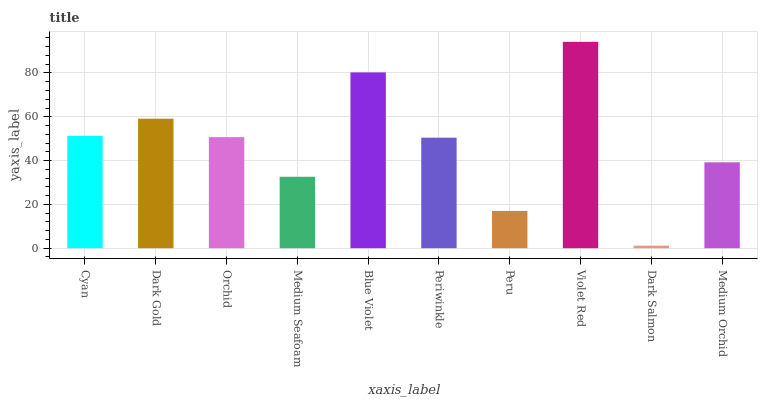Is Dark Salmon the minimum?
Answer yes or no. Yes. Is Violet Red the maximum?
Answer yes or no. Yes. Is Dark Gold the minimum?
Answer yes or no. No. Is Dark Gold the maximum?
Answer yes or no. No. Is Dark Gold greater than Cyan?
Answer yes or no. Yes. Is Cyan less than Dark Gold?
Answer yes or no. Yes. Is Cyan greater than Dark Gold?
Answer yes or no. No. Is Dark Gold less than Cyan?
Answer yes or no. No. Is Orchid the high median?
Answer yes or no. Yes. Is Periwinkle the low median?
Answer yes or no. Yes. Is Periwinkle the high median?
Answer yes or no. No. Is Dark Salmon the low median?
Answer yes or no. No. 